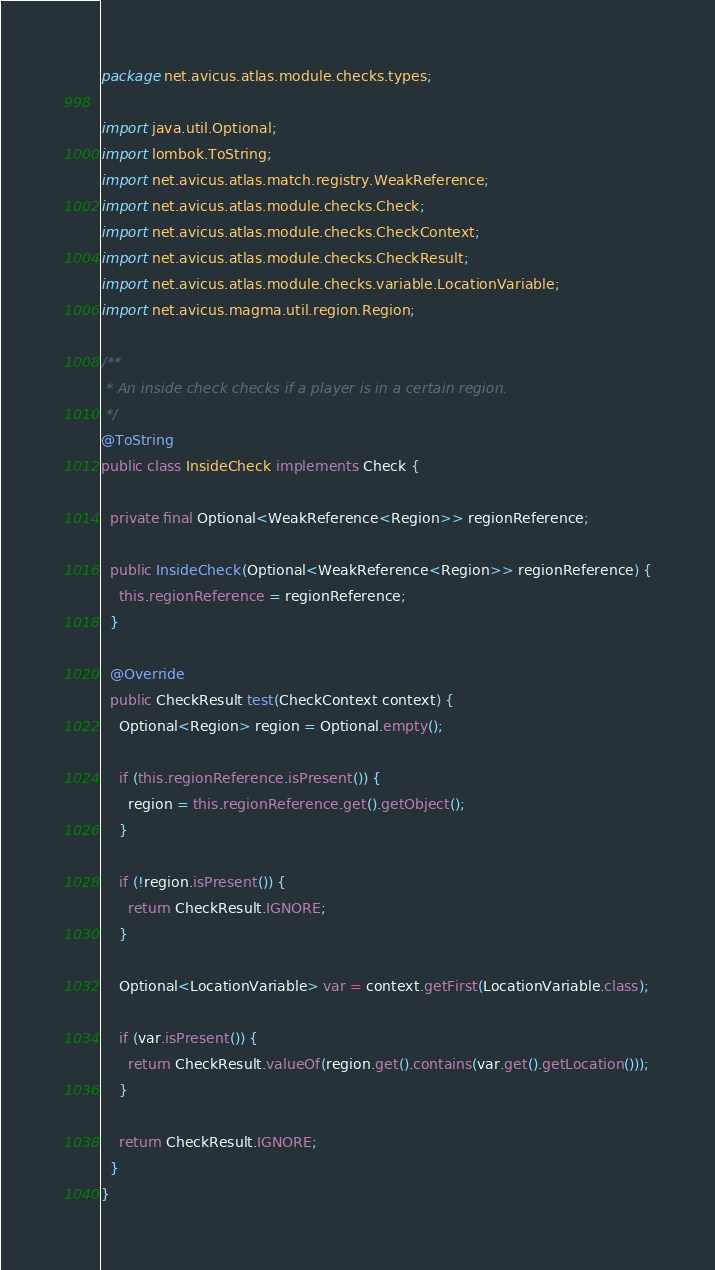<code> <loc_0><loc_0><loc_500><loc_500><_Java_>package net.avicus.atlas.module.checks.types;

import java.util.Optional;
import lombok.ToString;
import net.avicus.atlas.match.registry.WeakReference;
import net.avicus.atlas.module.checks.Check;
import net.avicus.atlas.module.checks.CheckContext;
import net.avicus.atlas.module.checks.CheckResult;
import net.avicus.atlas.module.checks.variable.LocationVariable;
import net.avicus.magma.util.region.Region;

/**
 * An inside check checks if a player is in a certain region.
 */
@ToString
public class InsideCheck implements Check {

  private final Optional<WeakReference<Region>> regionReference;

  public InsideCheck(Optional<WeakReference<Region>> regionReference) {
    this.regionReference = regionReference;
  }

  @Override
  public CheckResult test(CheckContext context) {
    Optional<Region> region = Optional.empty();

    if (this.regionReference.isPresent()) {
      region = this.regionReference.get().getObject();
    }

    if (!region.isPresent()) {
      return CheckResult.IGNORE;
    }

    Optional<LocationVariable> var = context.getFirst(LocationVariable.class);

    if (var.isPresent()) {
      return CheckResult.valueOf(region.get().contains(var.get().getLocation()));
    }

    return CheckResult.IGNORE;
  }
}
</code> 